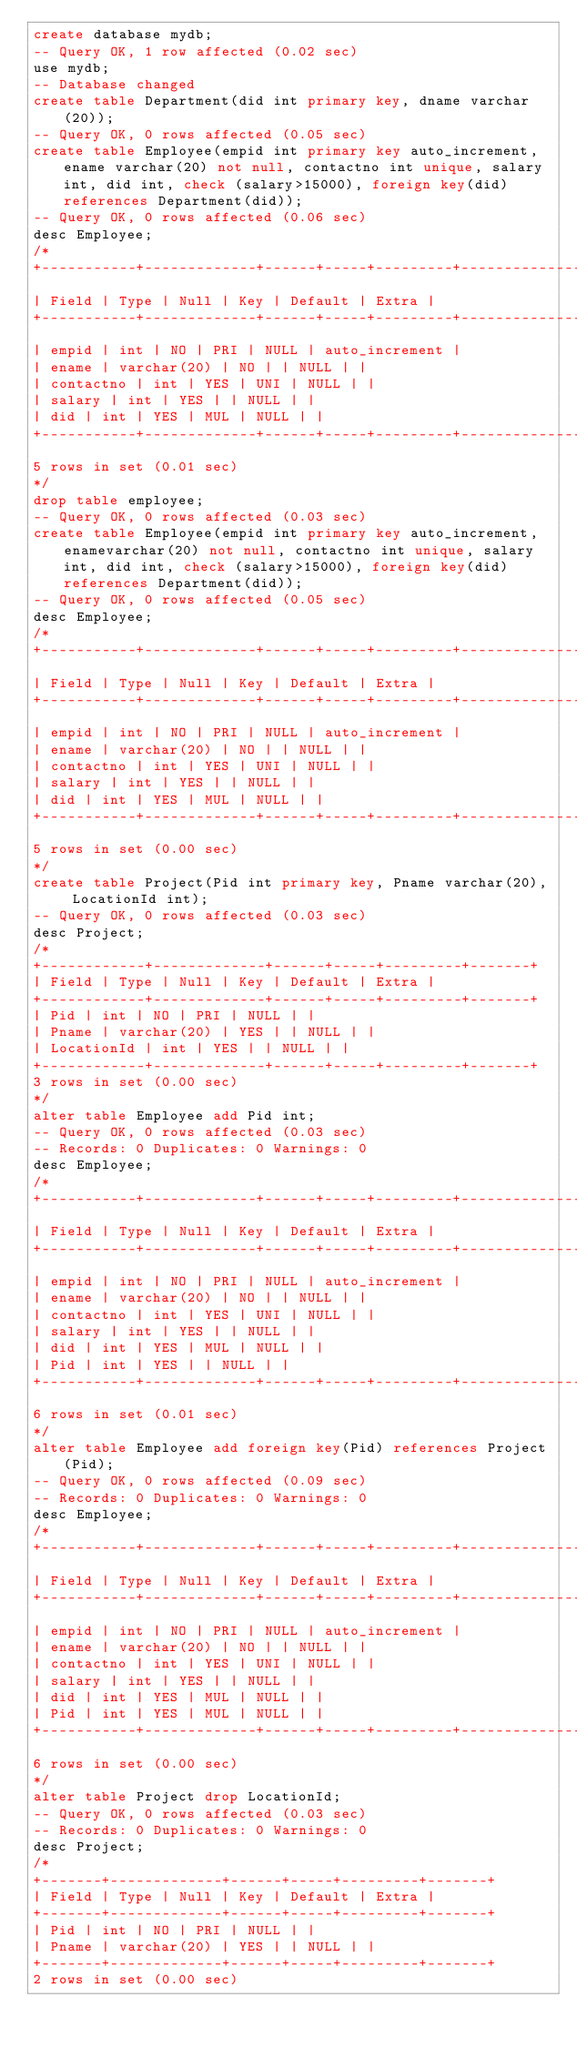Convert code to text. <code><loc_0><loc_0><loc_500><loc_500><_SQL_>create database mydb;
-- Query OK, 1 row affected (0.02 sec)
use mydb;
-- Database changed
create table Department(did int primary key, dname varchar(20));
-- Query OK, 0 rows affected (0.05 sec)
create table Employee(empid int primary key auto_increment, ename varchar(20) not null, contactno int unique, salary int, did int, check (salary>15000), foreign key(did) references Department(did));
-- Query OK, 0 rows affected (0.06 sec)
desc Employee;
/*
+-----------+-------------+------+-----+---------+----------------+
| Field | Type | Null | Key | Default | Extra |
+-----------+-------------+------+-----+---------+----------------+
| empid | int | NO | PRI | NULL | auto_increment |
| ename | varchar(20) | NO | | NULL | |
| contactno | int | YES | UNI | NULL | |
| salary | int | YES | | NULL | |
| did | int | YES | MUL | NULL | |
+-----------+-------------+------+-----+---------+----------------+
5 rows in set (0.01 sec)
*/
drop table employee;
-- Query OK, 0 rows affected (0.03 sec)
create table Employee(empid int primary key auto_increment, enamevarchar(20) not null, contactno int unique, salary int, did int, check (salary>15000), foreign key(did) references Department(did));
-- Query OK, 0 rows affected (0.05 sec)
desc Employee;
/*
+-----------+-------------+------+-----+---------+----------------+
| Field | Type | Null | Key | Default | Extra |
+-----------+-------------+------+-----+---------+----------------+
| empid | int | NO | PRI | NULL | auto_increment |
| ename | varchar(20) | NO | | NULL | |
| contactno | int | YES | UNI | NULL | |
| salary | int | YES | | NULL | |
| did | int | YES | MUL | NULL | |
+-----------+-------------+------+-----+---------+----------------+
5 rows in set (0.00 sec)
*/
create table Project(Pid int primary key, Pname varchar(20), LocationId int);
-- Query OK, 0 rows affected (0.03 sec)
desc Project;
/*
+------------+-------------+------+-----+---------+-------+
| Field | Type | Null | Key | Default | Extra |
+------------+-------------+------+-----+---------+-------+
| Pid | int | NO | PRI | NULL | |
| Pname | varchar(20) | YES | | NULL | |
| LocationId | int | YES | | NULL | |
+------------+-------------+------+-----+---------+-------+
3 rows in set (0.00 sec)
*/
alter table Employee add Pid int;
-- Query OK, 0 rows affected (0.03 sec)
-- Records: 0 Duplicates: 0 Warnings: 0
desc Employee;
/*
+-----------+-------------+------+-----+---------+----------------+
| Field | Type | Null | Key | Default | Extra |
+-----------+-------------+------+-----+---------+----------------+
| empid | int | NO | PRI | NULL | auto_increment |
| ename | varchar(20) | NO | | NULL | |
| contactno | int | YES | UNI | NULL | |
| salary | int | YES | | NULL | |
| did | int | YES | MUL | NULL | |
| Pid | int | YES | | NULL | |
+-----------+-------------+------+-----+---------+----------------+
6 rows in set (0.01 sec)
*/
alter table Employee add foreign key(Pid) references Project(Pid);
-- Query OK, 0 rows affected (0.09 sec)
-- Records: 0 Duplicates: 0 Warnings: 0
desc Employee;
/*
+-----------+-------------+------+-----+---------+----------------+
| Field | Type | Null | Key | Default | Extra |
+-----------+-------------+------+-----+---------+----------------+
| empid | int | NO | PRI | NULL | auto_increment |
| ename | varchar(20) | NO | | NULL | |
| contactno | int | YES | UNI | NULL | |
| salary | int | YES | | NULL | |
| did | int | YES | MUL | NULL | |
| Pid | int | YES | MUL | NULL | |
+-----------+-------------+------+-----+---------+----------------+
6 rows in set (0.00 sec)
*/
alter table Project drop LocationId;
-- Query OK, 0 rows affected (0.03 sec)
-- Records: 0 Duplicates: 0 Warnings: 0
desc Project;
/*
+-------+-------------+------+-----+---------+-------+
| Field | Type | Null | Key | Default | Extra |
+-------+-------------+------+-----+---------+-------+
| Pid | int | NO | PRI | NULL | |
| Pname | varchar(20) | YES | | NULL | |
+-------+-------------+------+-----+---------+-------+
2 rows in set (0.00 sec)</code> 